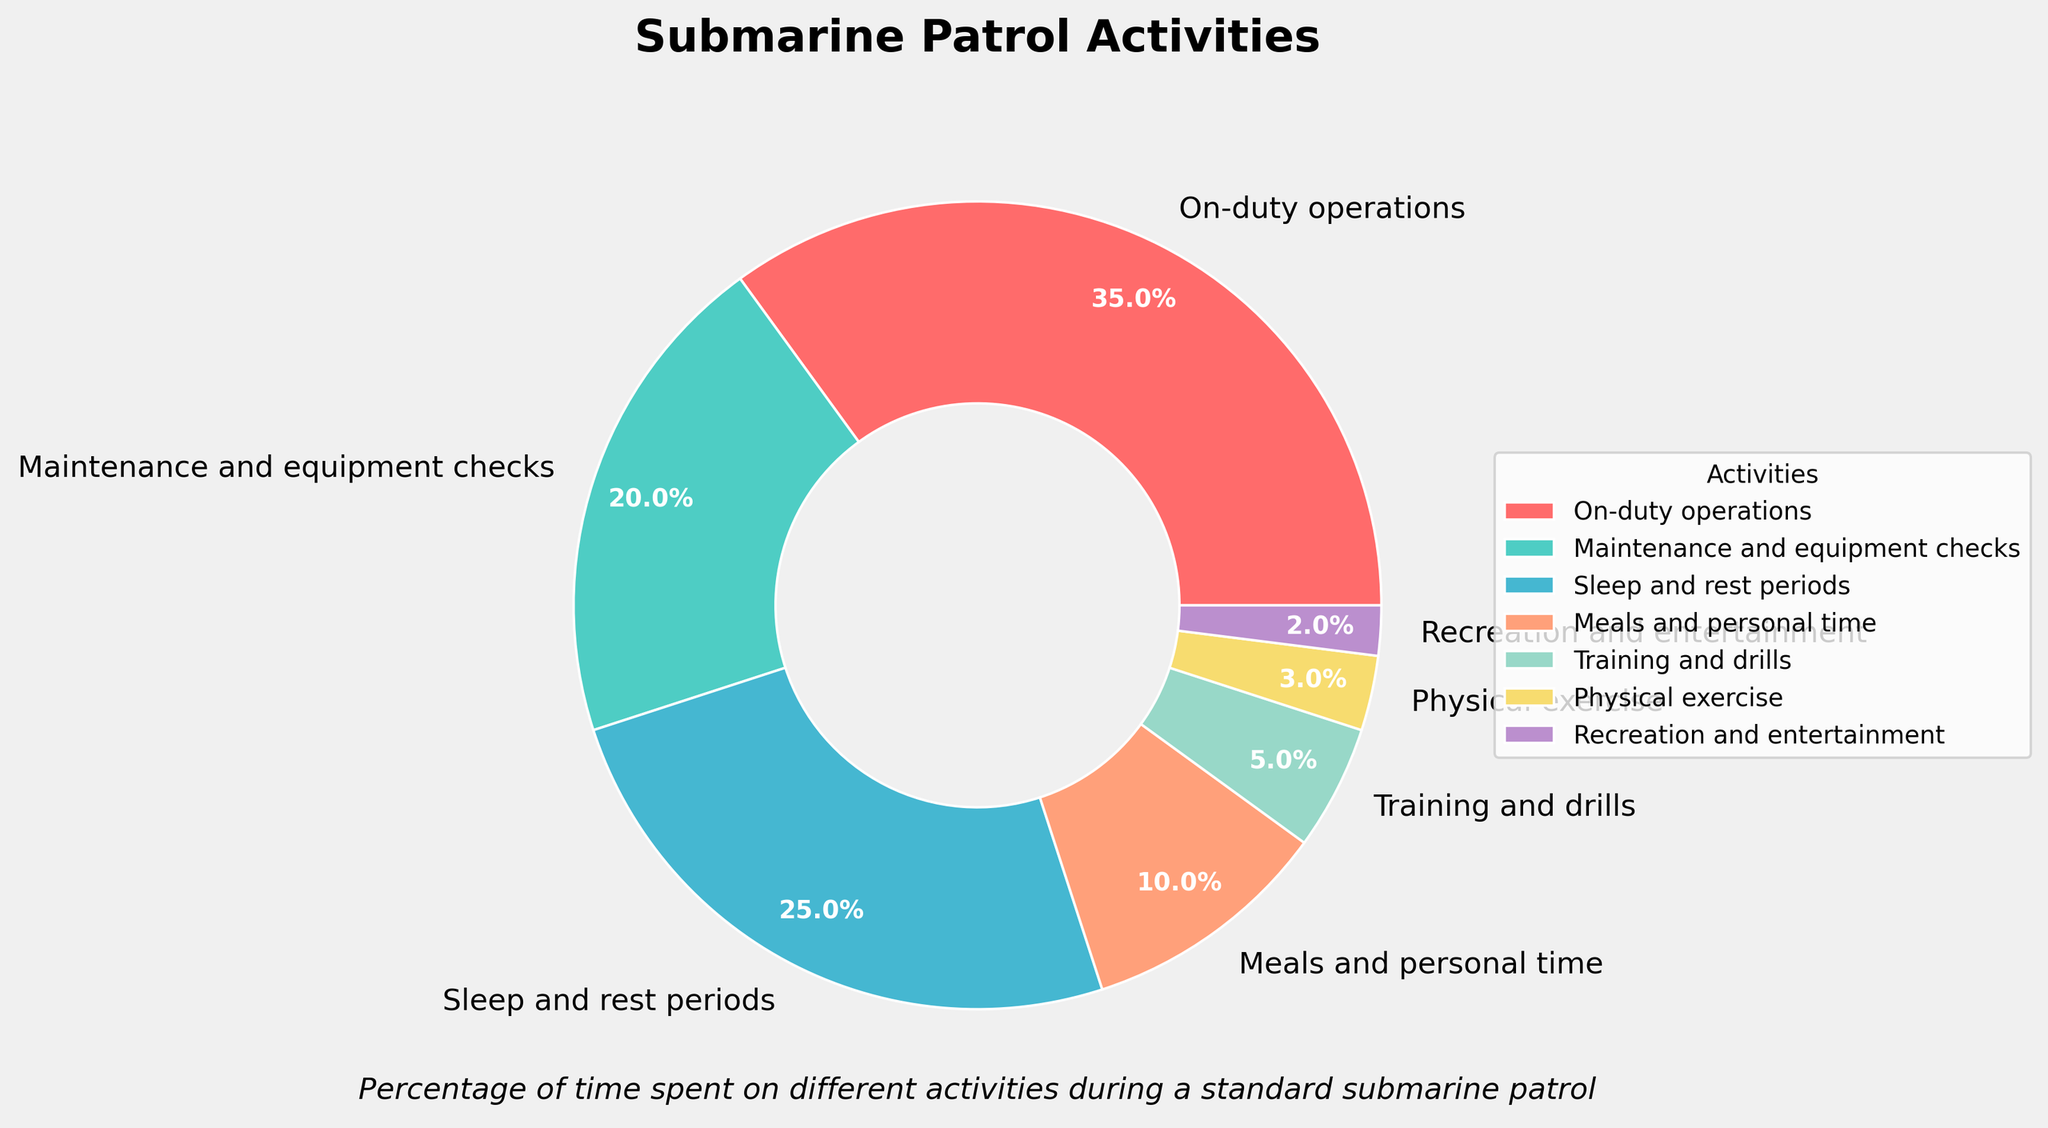what percentage of time is spent on physical exercise and recreation combined? To find the combined percentage, add the percentages for physical exercise and recreation and entertainment. From the data, physical exercise is 3% and recreation and entertainment is 2%. So, 3% + 2% = 5%
Answer: 5% which activity occupies the largest portion of time? The slice with the largest percentage represents the activity with the largest portion of time. From the data, on-duty operations have 35%, which is higher than any other single activity.
Answer: On-duty operations is the time spent on meals and personal time more than the time spent on training and drills? Compare the percentages for meals and personal time (10%) and training and drills (5%). Since 10% is greater than 5%, meals and personal time occupy more time.
Answer: Yes what is the difference in percentage between the time spent on maintenance and equipment checks and sleep and rest periods? Subtract the percentage of time spent on sleep and rest periods (25%) from the time spent on maintenance and equipment checks (20%). 20% - 25% = -5%. The negative value indicates that less time is spent on maintenance and equipment checks.
Answer: -5% which activity takes up less time, physical exercise or recreation and entertainment? Compare the slices for physical exercise and recreation and entertainment. From the data, physical exercise takes up 3% and recreation and entertainment takes up 2%.
Answer: Recreation and entertainment how much more time is spent on on-duty operations compared to meals and personal time? Subtract the percentage of time spent on meals and personal time (10%) from the time spent on on-duty operations (35%). 35% - 10% = 25%
Answer: 25% what color represents the time spent on training and drills? Look at the visualization and locate the slice labeled "Training and Drills" to identify its color. From the data, the specified color sequence indicates that the corresponding color is '#98D8C8', which is a light green color.
Answer: Light green what is the average percentage of time spent on maintenance and equipment checks, meals and personal time, and physical exercise? Sum the percentages of maintenance and equipment checks (20%), meals and personal time (10%), and physical exercise (3%). 20% + 10% + 3% = 33%. Then, divide by the number of activities, which is 3. 33% / 3 = 11%
Answer: 11% what slice on the pie does the least amount of time represent? The smallest slice on the pie chart indicates the least amount of time. From the data, recreation and entertainment is 2%, which is less than any other category.
Answer: Recreation and entertainment how many activities take up 20% or more of the time? Examine each activity's percentage and count how many are 20% or more. From the data, on-duty operations (35%), maintenance and equipment checks (20%), and sleep and rest periods (25%) meet this criterion. So, there are 3 activities.
Answer: 3 